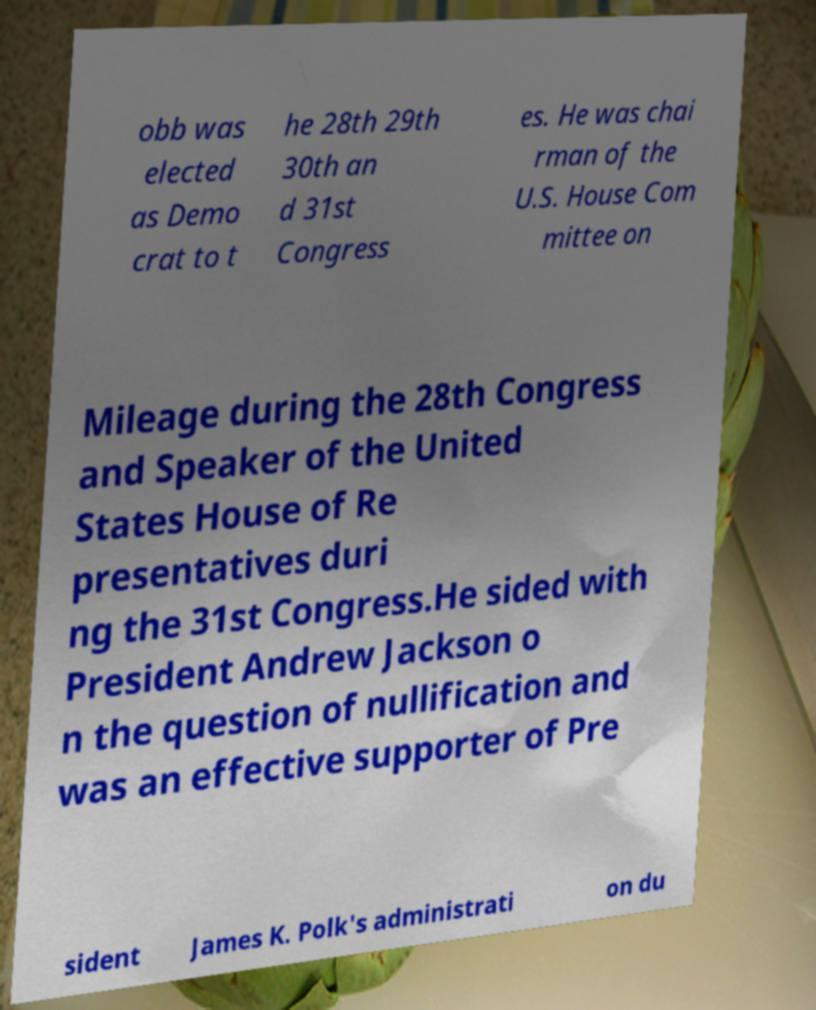Can you read and provide the text displayed in the image?This photo seems to have some interesting text. Can you extract and type it out for me? obb was elected as Demo crat to t he 28th 29th 30th an d 31st Congress es. He was chai rman of the U.S. House Com mittee on Mileage during the 28th Congress and Speaker of the United States House of Re presentatives duri ng the 31st Congress.He sided with President Andrew Jackson o n the question of nullification and was an effective supporter of Pre sident James K. Polk's administrati on du 